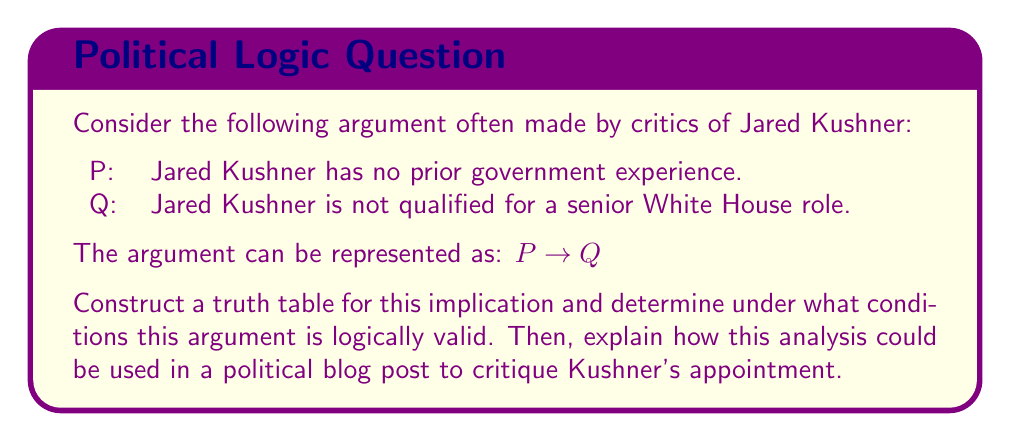Can you solve this math problem? To analyze this argument using a truth table, we need to consider all possible truth values for P and Q and evaluate the implication $P \rightarrow Q$. 

First, let's construct the truth table:

$$
\begin{array}{|c|c|c|}
\hline
P & Q & P \rightarrow Q \\
\hline
T & T & T \\
T & F & F \\
F & T & T \\
F & F & T \\
\hline
\end{array}
$$

In this truth table:
- T represents "True"
- F represents "False"
- $P \rightarrow Q$ is false only when P is true and Q is false

The implication $P \rightarrow Q$ is logically valid in all cases except when P is true and Q is false. This means the argument is valid as long as it's not the case that Kushner has no prior government experience (P is true) but is qualified for a senior White House role (Q is false).

In the context of a political blog post, this analysis could be used as follows:

1. Explain that the argument's logical structure is sound. If the premise (P) is accepted as true, then the conclusion (Q) must follow for the argument to be valid.

2. Point out that the only way to refute this argument logically would be to show that Kushner has no prior government experience BUT is still qualified for a senior White House role. This puts the burden of proof on Kushner's defenders.

3. Highlight that in all other scenarios - even if Kushner had prior government experience - the argument remains logically consistent.

4. Emphasize that this logical analysis supports the skepticism of Kushner's competence, as it demonstrates the difficulty in logically justifying his qualifications given his lack of experience.

5. Conclude that unless compelling evidence can be provided to show Kushner's qualifications despite his lack of experience, the logical structure of the argument supports the criticism of his appointment.
Answer: The argument $P \rightarrow Q$ is logically valid in all cases except when P is true and Q is false. In the context of critiquing Kushner's appointment, this means the argument is logically sound unless it can be demonstrated that Kushner has no prior government experience but is still qualified for a senior White House role. 